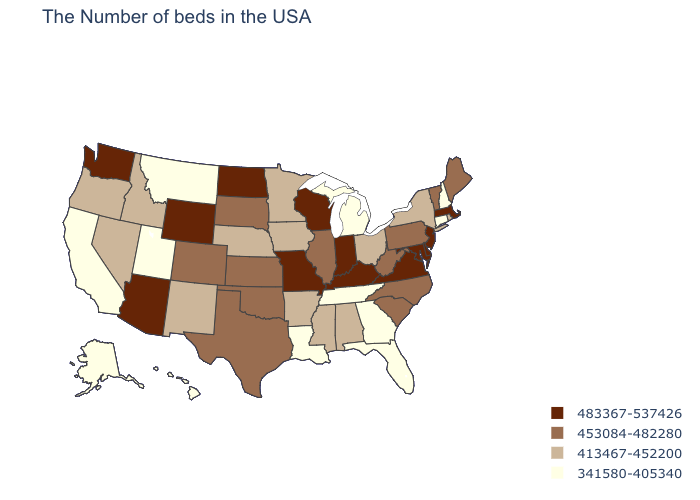Does Delaware have the highest value in the South?
Give a very brief answer. Yes. Name the states that have a value in the range 341580-405340?
Short answer required. New Hampshire, Connecticut, Florida, Georgia, Michigan, Tennessee, Louisiana, Utah, Montana, California, Alaska, Hawaii. What is the lowest value in states that border New Hampshire?
Concise answer only. 453084-482280. Does Missouri have a higher value than Illinois?
Write a very short answer. Yes. Does Missouri have the highest value in the USA?
Be succinct. Yes. Does the map have missing data?
Be succinct. No. Among the states that border Indiana , does Kentucky have the highest value?
Concise answer only. Yes. What is the lowest value in the USA?
Give a very brief answer. 341580-405340. What is the value of Arkansas?
Keep it brief. 413467-452200. Name the states that have a value in the range 341580-405340?
Quick response, please. New Hampshire, Connecticut, Florida, Georgia, Michigan, Tennessee, Louisiana, Utah, Montana, California, Alaska, Hawaii. What is the highest value in states that border New York?
Short answer required. 483367-537426. Does New Jersey have the highest value in the Northeast?
Be succinct. Yes. Name the states that have a value in the range 413467-452200?
Write a very short answer. Rhode Island, New York, Ohio, Alabama, Mississippi, Arkansas, Minnesota, Iowa, Nebraska, New Mexico, Idaho, Nevada, Oregon. What is the value of Michigan?
Keep it brief. 341580-405340. Which states have the lowest value in the West?
Answer briefly. Utah, Montana, California, Alaska, Hawaii. 